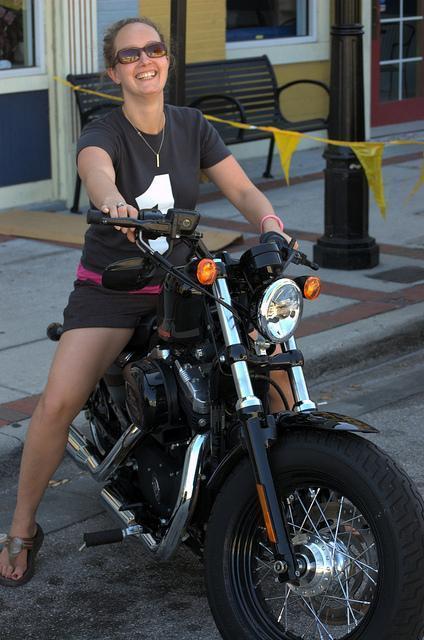How many white plastic forks are there?
Give a very brief answer. 0. 